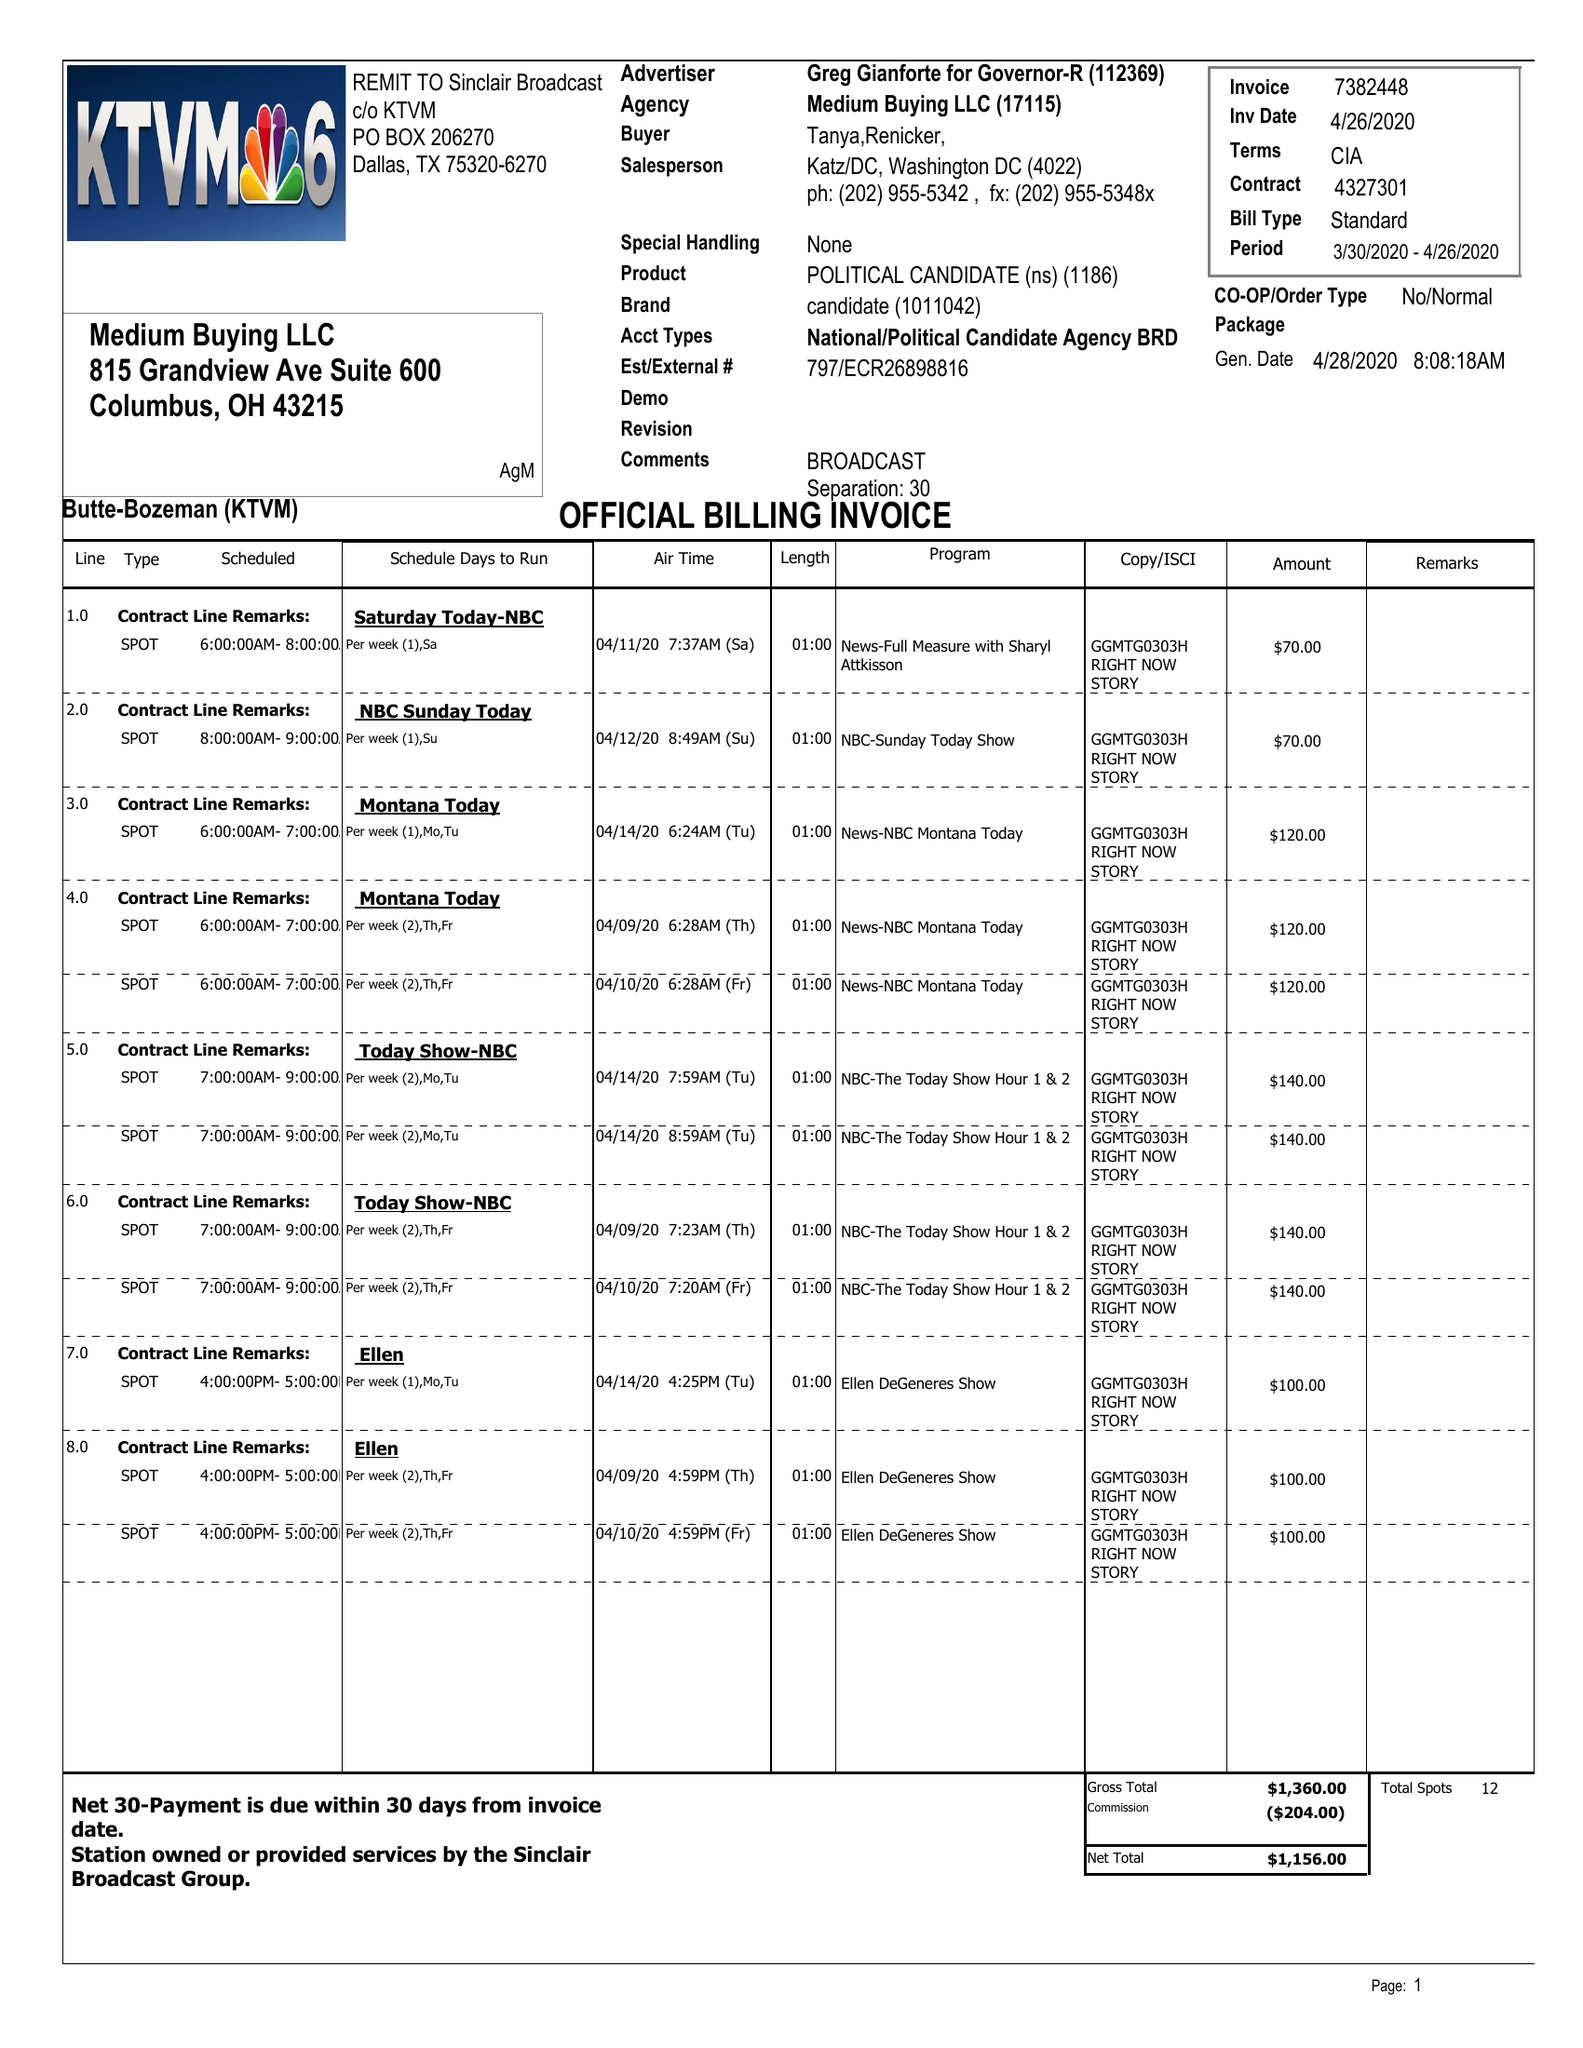What is the value for the flight_to?
Answer the question using a single word or phrase. 04/26/20 